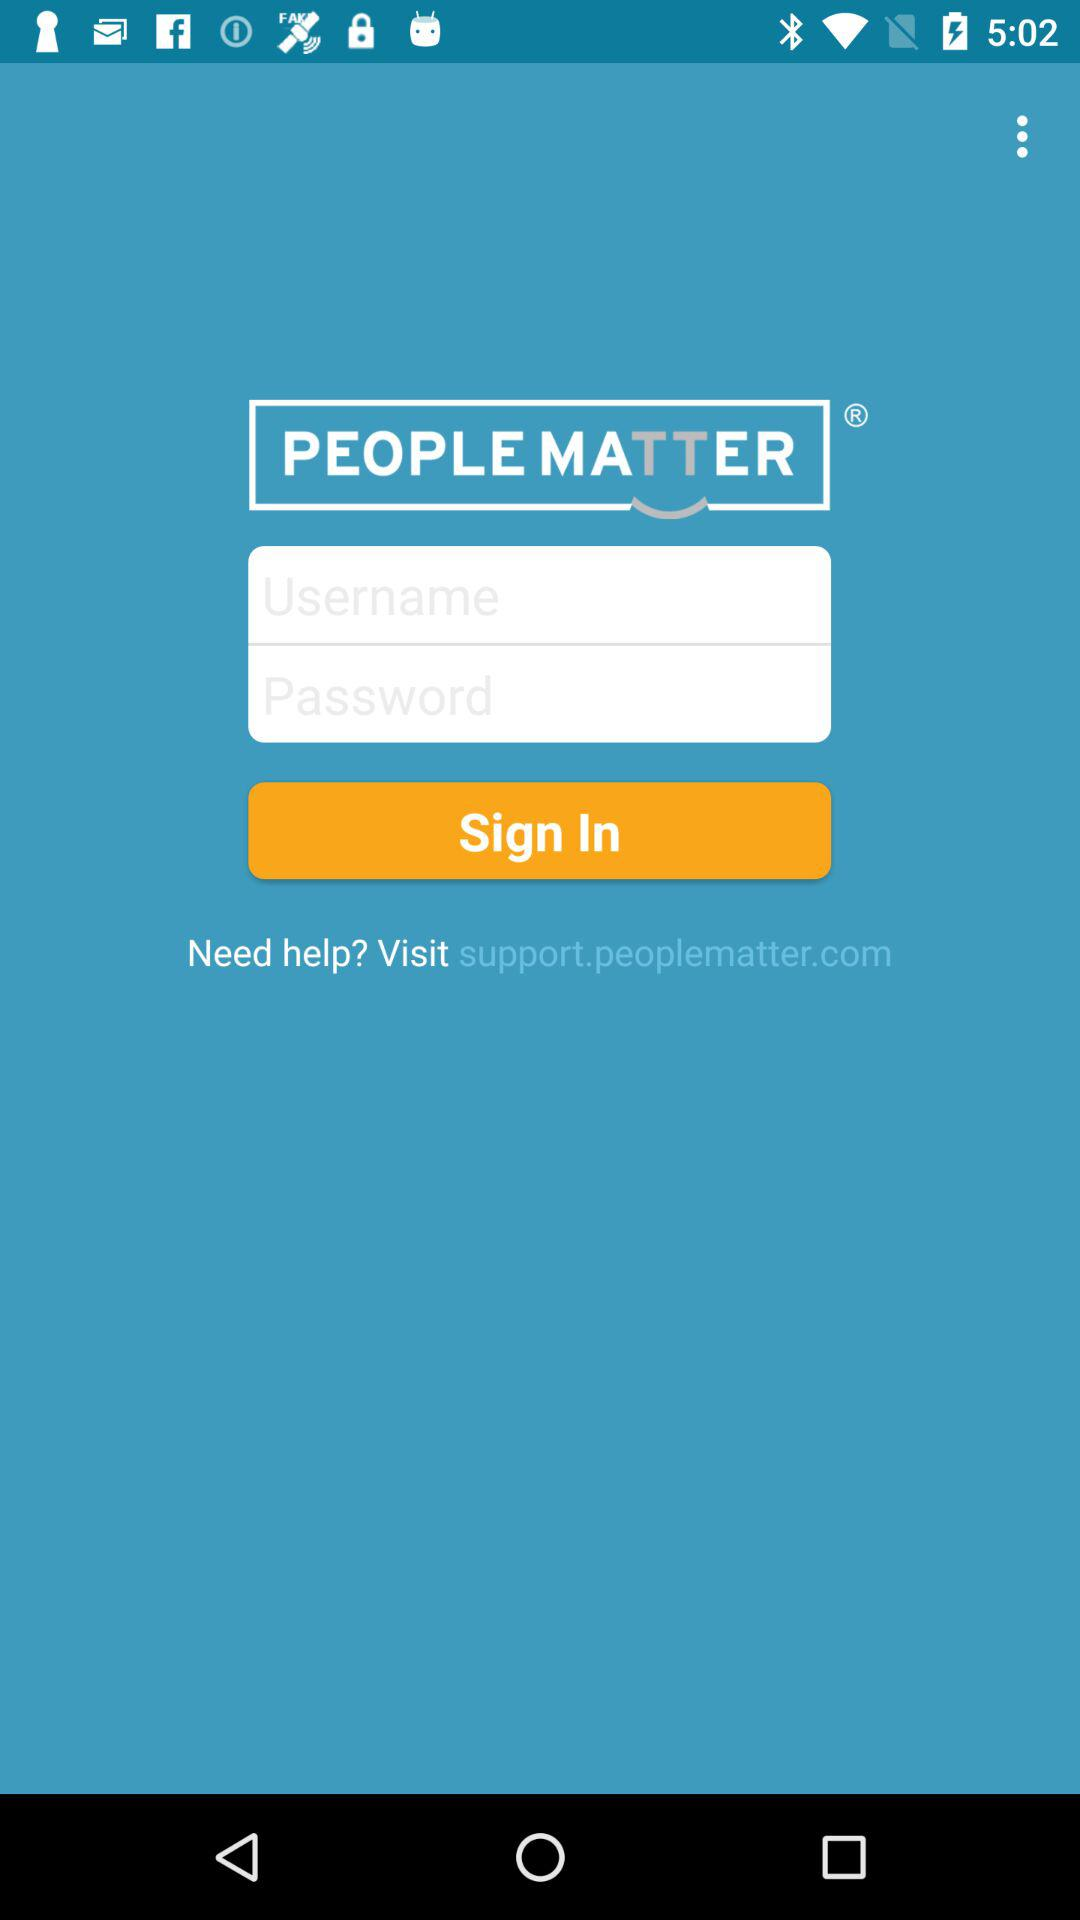What is the name of the application? The name of the application is "PEOPLEMATTER". 